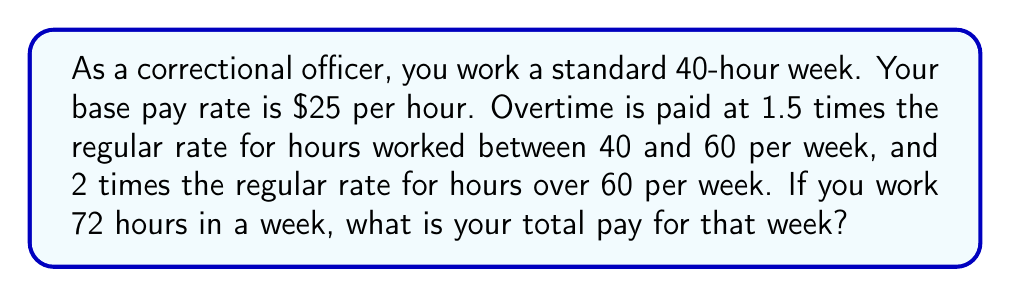Teach me how to tackle this problem. Let's break this down step-by-step:

1. Calculate regular pay:
   Regular hours = 40
   Regular pay = $25 × 40 = $1000

2. Calculate overtime pay for hours 41-60:
   Overtime hours (1.5x rate) = 20
   Overtime rate = $25 × 1.5 = $37.50
   Overtime pay (1.5x) = $37.50 × 20 = $750

3. Calculate overtime pay for hours 61-72:
   Overtime hours (2x rate) = 72 - 60 = 12
   Overtime rate = $25 × 2 = $50
   Overtime pay (2x) = $50 × 12 = $600

4. Sum up total pay:
   Total pay = Regular pay + Overtime pay (1.5x) + Overtime pay (2x)
   Total pay = $1000 + $750 + $600 = $2350

Therefore, your total pay for the 72-hour week is $2350.
Answer: $2350 